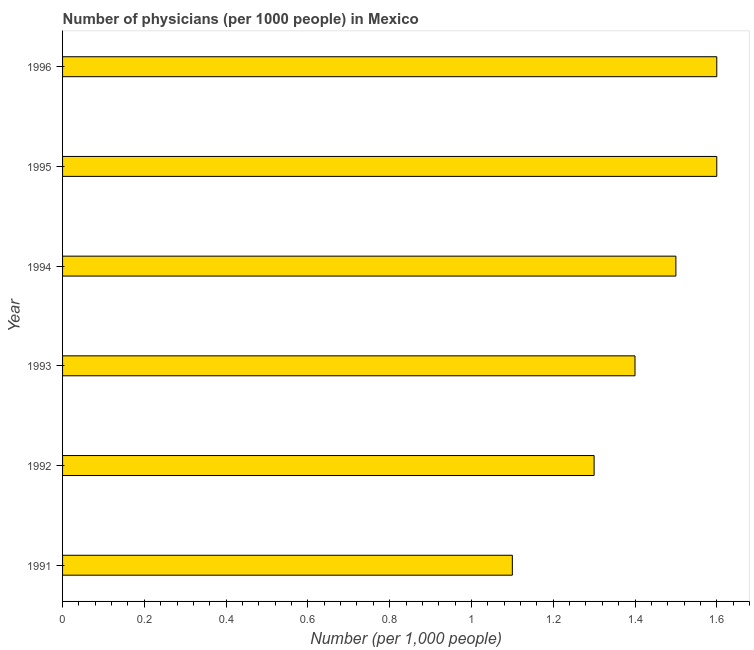Does the graph contain grids?
Your response must be concise. No. What is the title of the graph?
Make the answer very short. Number of physicians (per 1000 people) in Mexico. What is the label or title of the X-axis?
Your answer should be compact. Number (per 1,0 people). What is the label or title of the Y-axis?
Your answer should be compact. Year. What is the number of physicians in 1992?
Your answer should be compact. 1.3. What is the sum of the number of physicians?
Provide a succinct answer. 8.5. What is the difference between the number of physicians in 1995 and 1996?
Ensure brevity in your answer.  0. What is the average number of physicians per year?
Provide a short and direct response. 1.42. What is the median number of physicians?
Provide a succinct answer. 1.45. In how many years, is the number of physicians greater than 0.56 ?
Offer a terse response. 6. Do a majority of the years between 1992 and 1994 (inclusive) have number of physicians greater than 1.48 ?
Give a very brief answer. No. What is the ratio of the number of physicians in 1992 to that in 1993?
Keep it short and to the point. 0.93. Is the number of physicians in 1991 less than that in 1994?
Make the answer very short. Yes. Is the difference between the number of physicians in 1993 and 1996 greater than the difference between any two years?
Give a very brief answer. No. What is the difference between the highest and the second highest number of physicians?
Offer a very short reply. 0. How many bars are there?
Provide a short and direct response. 6. Are all the bars in the graph horizontal?
Your response must be concise. Yes. How many years are there in the graph?
Offer a very short reply. 6. What is the Number (per 1,000 people) of 1993?
Offer a terse response. 1.4. What is the Number (per 1,000 people) in 1994?
Make the answer very short. 1.5. What is the Number (per 1,000 people) of 1996?
Make the answer very short. 1.6. What is the difference between the Number (per 1,000 people) in 1991 and 1992?
Provide a succinct answer. -0.2. What is the difference between the Number (per 1,000 people) in 1991 and 1994?
Provide a succinct answer. -0.4. What is the difference between the Number (per 1,000 people) in 1991 and 1995?
Your response must be concise. -0.5. What is the difference between the Number (per 1,000 people) in 1991 and 1996?
Keep it short and to the point. -0.5. What is the difference between the Number (per 1,000 people) in 1992 and 1995?
Provide a succinct answer. -0.3. What is the difference between the Number (per 1,000 people) in 1993 and 1994?
Make the answer very short. -0.1. What is the difference between the Number (per 1,000 people) in 1993 and 1995?
Your answer should be compact. -0.2. What is the difference between the Number (per 1,000 people) in 1993 and 1996?
Ensure brevity in your answer.  -0.2. What is the difference between the Number (per 1,000 people) in 1994 and 1996?
Ensure brevity in your answer.  -0.1. What is the difference between the Number (per 1,000 people) in 1995 and 1996?
Offer a terse response. 0. What is the ratio of the Number (per 1,000 people) in 1991 to that in 1992?
Make the answer very short. 0.85. What is the ratio of the Number (per 1,000 people) in 1991 to that in 1993?
Provide a succinct answer. 0.79. What is the ratio of the Number (per 1,000 people) in 1991 to that in 1994?
Provide a succinct answer. 0.73. What is the ratio of the Number (per 1,000 people) in 1991 to that in 1995?
Offer a very short reply. 0.69. What is the ratio of the Number (per 1,000 people) in 1991 to that in 1996?
Offer a terse response. 0.69. What is the ratio of the Number (per 1,000 people) in 1992 to that in 1993?
Offer a very short reply. 0.93. What is the ratio of the Number (per 1,000 people) in 1992 to that in 1994?
Provide a succinct answer. 0.87. What is the ratio of the Number (per 1,000 people) in 1992 to that in 1995?
Offer a very short reply. 0.81. What is the ratio of the Number (per 1,000 people) in 1992 to that in 1996?
Offer a terse response. 0.81. What is the ratio of the Number (per 1,000 people) in 1993 to that in 1994?
Give a very brief answer. 0.93. What is the ratio of the Number (per 1,000 people) in 1994 to that in 1995?
Give a very brief answer. 0.94. What is the ratio of the Number (per 1,000 people) in 1994 to that in 1996?
Give a very brief answer. 0.94. What is the ratio of the Number (per 1,000 people) in 1995 to that in 1996?
Provide a short and direct response. 1. 